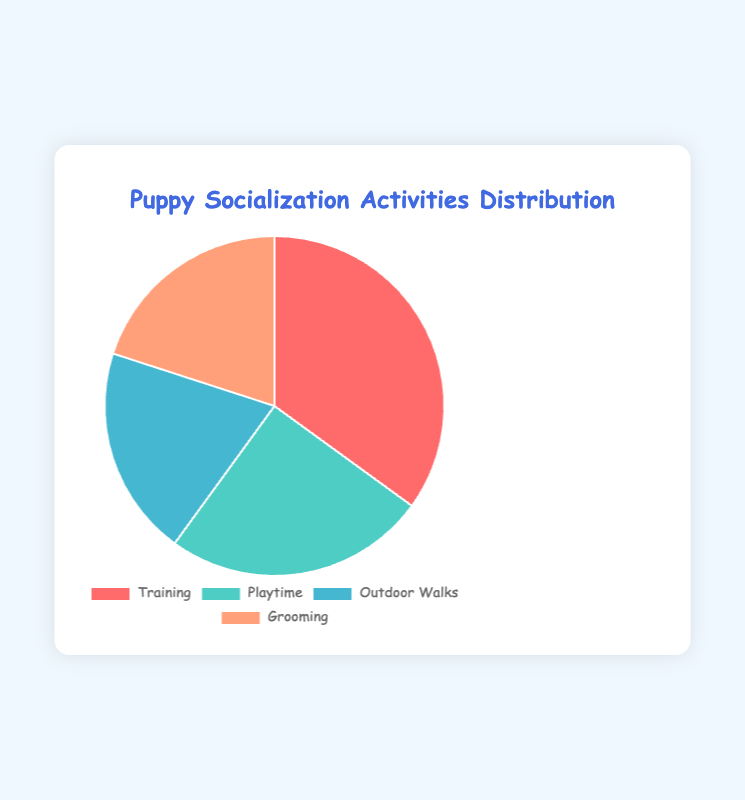What's the most common puppy socialization activity? The pie chart visually shows the activity distribution with the slice sizes representing their percentages. The largest slice belongs to "Training" with 35%.
Answer: Training What's the combined percentage of Outdoor Walks and Grooming? The pie chart provides the percentages for each activity. Adding the percentages for "Outdoor Walks" (20%) and "Grooming" (20%) gives: 20% + 20% = 40%.
Answer: 40% Which activity is less common, Playtime or Grooming? The pie chart shows Playtime at 25% and Grooming at 20%. Since 20% is less than 25%, Grooming is less common.
Answer: Grooming By what percentage does Training exceed Playtime? The pie chart indicates Training is 35% and Playtime is 25%. The difference is calculated as 35% - 25% = 10%.
Answer: 10% If we were to combine Playtime and Outdoor Walks into a single category called "Recreation," what percentage would that category represent? From the chart, Playtime is 25% and Outdoor Walks is 20%. Adding these gives: 25% + 20% = 45%.
Answer: 45% Which activities have an equal distribution in the pie chart? Observing the chart, Outdoor Walks and Grooming each have a percentage of 20%. Thus, they have equal distribution.
Answer: Outdoor Walks and Grooming If Grooming and Outdoor Walks were reduced by half, what would be their new percentages? Original percentages for Grooming and Outdoor Walks are 20% each. Halving them gives: 20% / 2 = 10% for each activity.
Answer: 10% for each What is the ratio of Training to Playtime? From the chart, Training is 35% and Playtime is 25%. The ratio is 35:25, which simplifies to 7:5.
Answer: 7:5 How much more percentage is spent on Training than on Outdoor Walks? The pie chart shows Training at 35% and Outdoor Walks at 20%. Subtracting the two gives: 35% - 20% = 15%.
Answer: 15% What is the average percentage of all activities? Adding all percentages: 35% (Training) + 25% (Playtime) + 20% (Outdoor Walks) + 20% (Grooming) = 100%. Dividing by the number of activities (4) gives: 100% / 4 = 25%.
Answer: 25% 